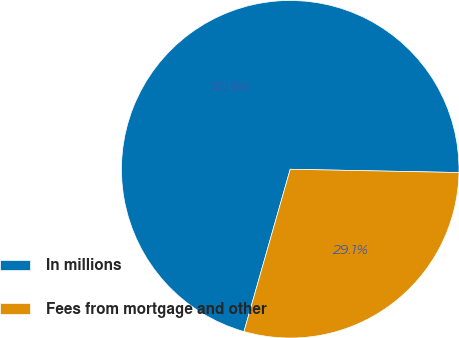Convert chart to OTSL. <chart><loc_0><loc_0><loc_500><loc_500><pie_chart><fcel>In millions<fcel>Fees from mortgage and other<nl><fcel>70.89%<fcel>29.11%<nl></chart> 